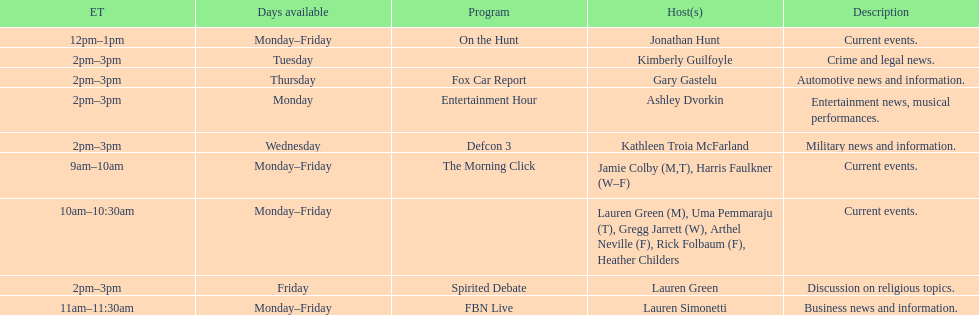How many days is fbn live available each week? 5. 